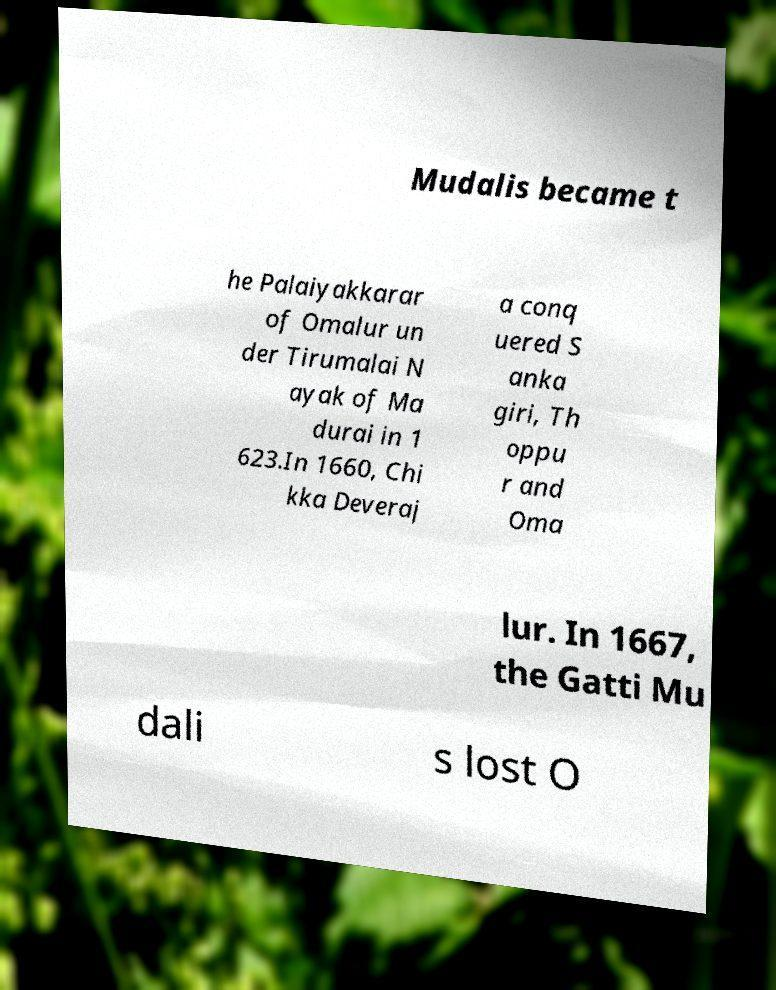I need the written content from this picture converted into text. Can you do that? Mudalis became t he Palaiyakkarar of Omalur un der Tirumalai N ayak of Ma durai in 1 623.In 1660, Chi kka Deveraj a conq uered S anka giri, Th oppu r and Oma lur. In 1667, the Gatti Mu dali s lost O 